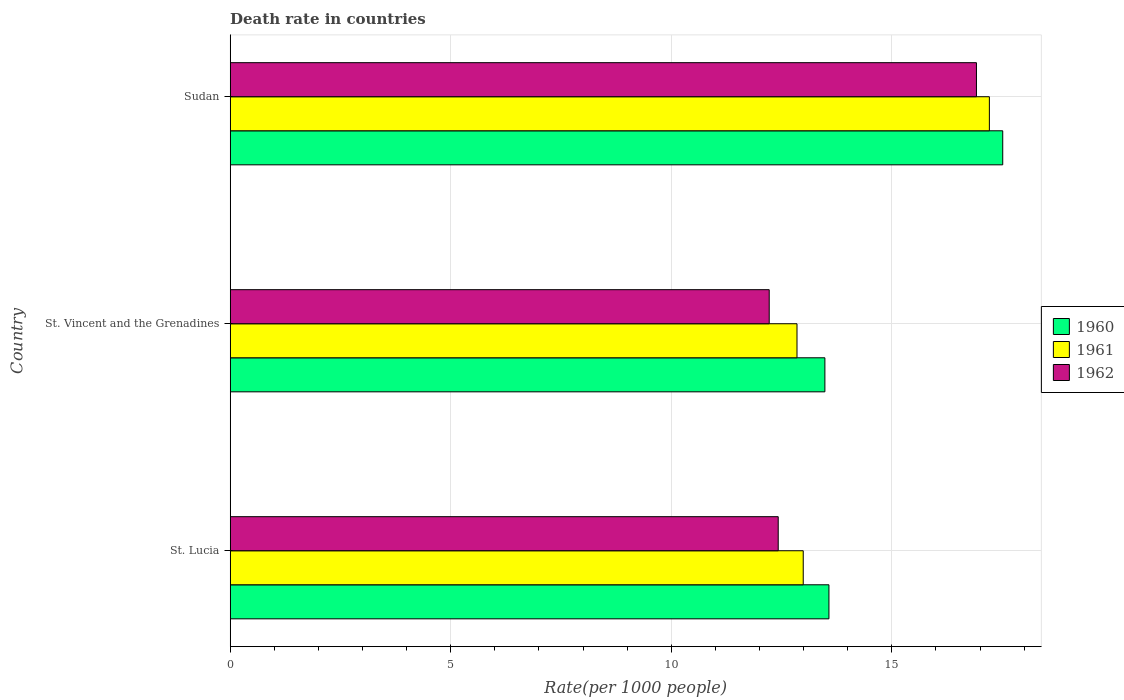How many bars are there on the 3rd tick from the top?
Provide a short and direct response. 3. What is the label of the 1st group of bars from the top?
Offer a terse response. Sudan. In how many cases, is the number of bars for a given country not equal to the number of legend labels?
Offer a very short reply. 0. What is the death rate in 1960 in St. Lucia?
Your answer should be very brief. 13.57. Across all countries, what is the maximum death rate in 1960?
Your answer should be compact. 17.51. Across all countries, what is the minimum death rate in 1961?
Ensure brevity in your answer.  12.85. In which country was the death rate in 1960 maximum?
Make the answer very short. Sudan. In which country was the death rate in 1960 minimum?
Provide a succinct answer. St. Vincent and the Grenadines. What is the total death rate in 1961 in the graph?
Offer a terse response. 43.05. What is the difference between the death rate in 1962 in St. Lucia and that in St. Vincent and the Grenadines?
Offer a terse response. 0.2. What is the difference between the death rate in 1960 in Sudan and the death rate in 1962 in St. Vincent and the Grenadines?
Ensure brevity in your answer.  5.29. What is the average death rate in 1962 per country?
Offer a terse response. 13.85. What is the difference between the death rate in 1961 and death rate in 1962 in St. Vincent and the Grenadines?
Your answer should be compact. 0.63. In how many countries, is the death rate in 1960 greater than 1 ?
Ensure brevity in your answer.  3. What is the ratio of the death rate in 1962 in St. Vincent and the Grenadines to that in Sudan?
Your response must be concise. 0.72. Is the difference between the death rate in 1961 in St. Lucia and Sudan greater than the difference between the death rate in 1962 in St. Lucia and Sudan?
Offer a very short reply. Yes. What is the difference between the highest and the second highest death rate in 1961?
Ensure brevity in your answer.  4.22. What is the difference between the highest and the lowest death rate in 1961?
Make the answer very short. 4.36. In how many countries, is the death rate in 1961 greater than the average death rate in 1961 taken over all countries?
Offer a terse response. 1. Is the sum of the death rate in 1962 in St. Lucia and Sudan greater than the maximum death rate in 1961 across all countries?
Offer a very short reply. Yes. Is it the case that in every country, the sum of the death rate in 1960 and death rate in 1961 is greater than the death rate in 1962?
Make the answer very short. Yes. Are all the bars in the graph horizontal?
Give a very brief answer. Yes. What is the difference between two consecutive major ticks on the X-axis?
Offer a very short reply. 5. Are the values on the major ticks of X-axis written in scientific E-notation?
Provide a short and direct response. No. Does the graph contain any zero values?
Ensure brevity in your answer.  No. Does the graph contain grids?
Your response must be concise. Yes. How many legend labels are there?
Provide a succinct answer. 3. What is the title of the graph?
Offer a terse response. Death rate in countries. Does "1979" appear as one of the legend labels in the graph?
Offer a terse response. No. What is the label or title of the X-axis?
Keep it short and to the point. Rate(per 1000 people). What is the Rate(per 1000 people) in 1960 in St. Lucia?
Offer a very short reply. 13.57. What is the Rate(per 1000 people) of 1961 in St. Lucia?
Provide a succinct answer. 12.99. What is the Rate(per 1000 people) in 1962 in St. Lucia?
Offer a very short reply. 12.42. What is the Rate(per 1000 people) of 1960 in St. Vincent and the Grenadines?
Provide a succinct answer. 13.48. What is the Rate(per 1000 people) of 1961 in St. Vincent and the Grenadines?
Your response must be concise. 12.85. What is the Rate(per 1000 people) of 1962 in St. Vincent and the Grenadines?
Ensure brevity in your answer.  12.22. What is the Rate(per 1000 people) of 1960 in Sudan?
Make the answer very short. 17.51. What is the Rate(per 1000 people) of 1961 in Sudan?
Give a very brief answer. 17.21. What is the Rate(per 1000 people) of 1962 in Sudan?
Provide a short and direct response. 16.92. Across all countries, what is the maximum Rate(per 1000 people) in 1960?
Offer a very short reply. 17.51. Across all countries, what is the maximum Rate(per 1000 people) in 1961?
Provide a succinct answer. 17.21. Across all countries, what is the maximum Rate(per 1000 people) of 1962?
Offer a terse response. 16.92. Across all countries, what is the minimum Rate(per 1000 people) of 1960?
Ensure brevity in your answer.  13.48. Across all countries, what is the minimum Rate(per 1000 people) of 1961?
Provide a succinct answer. 12.85. Across all countries, what is the minimum Rate(per 1000 people) of 1962?
Provide a short and direct response. 12.22. What is the total Rate(per 1000 people) of 1960 in the graph?
Your answer should be very brief. 44.57. What is the total Rate(per 1000 people) of 1961 in the graph?
Your response must be concise. 43.05. What is the total Rate(per 1000 people) of 1962 in the graph?
Your answer should be very brief. 41.56. What is the difference between the Rate(per 1000 people) of 1960 in St. Lucia and that in St. Vincent and the Grenadines?
Offer a very short reply. 0.09. What is the difference between the Rate(per 1000 people) in 1961 in St. Lucia and that in St. Vincent and the Grenadines?
Your answer should be compact. 0.14. What is the difference between the Rate(per 1000 people) of 1962 in St. Lucia and that in St. Vincent and the Grenadines?
Provide a succinct answer. 0.2. What is the difference between the Rate(per 1000 people) in 1960 in St. Lucia and that in Sudan?
Provide a short and direct response. -3.94. What is the difference between the Rate(per 1000 people) in 1961 in St. Lucia and that in Sudan?
Your answer should be very brief. -4.22. What is the difference between the Rate(per 1000 people) in 1962 in St. Lucia and that in Sudan?
Offer a terse response. -4.49. What is the difference between the Rate(per 1000 people) in 1960 in St. Vincent and the Grenadines and that in Sudan?
Give a very brief answer. -4.03. What is the difference between the Rate(per 1000 people) of 1961 in St. Vincent and the Grenadines and that in Sudan?
Make the answer very short. -4.36. What is the difference between the Rate(per 1000 people) of 1962 in St. Vincent and the Grenadines and that in Sudan?
Make the answer very short. -4.7. What is the difference between the Rate(per 1000 people) in 1960 in St. Lucia and the Rate(per 1000 people) in 1961 in St. Vincent and the Grenadines?
Offer a very short reply. 0.72. What is the difference between the Rate(per 1000 people) in 1960 in St. Lucia and the Rate(per 1000 people) in 1962 in St. Vincent and the Grenadines?
Your answer should be very brief. 1.35. What is the difference between the Rate(per 1000 people) of 1961 in St. Lucia and the Rate(per 1000 people) of 1962 in St. Vincent and the Grenadines?
Your response must be concise. 0.77. What is the difference between the Rate(per 1000 people) in 1960 in St. Lucia and the Rate(per 1000 people) in 1961 in Sudan?
Offer a terse response. -3.64. What is the difference between the Rate(per 1000 people) of 1960 in St. Lucia and the Rate(per 1000 people) of 1962 in Sudan?
Keep it short and to the point. -3.34. What is the difference between the Rate(per 1000 people) in 1961 in St. Lucia and the Rate(per 1000 people) in 1962 in Sudan?
Give a very brief answer. -3.93. What is the difference between the Rate(per 1000 people) in 1960 in St. Vincent and the Grenadines and the Rate(per 1000 people) in 1961 in Sudan?
Provide a succinct answer. -3.73. What is the difference between the Rate(per 1000 people) in 1960 in St. Vincent and the Grenadines and the Rate(per 1000 people) in 1962 in Sudan?
Give a very brief answer. -3.44. What is the difference between the Rate(per 1000 people) in 1961 in St. Vincent and the Grenadines and the Rate(per 1000 people) in 1962 in Sudan?
Make the answer very short. -4.07. What is the average Rate(per 1000 people) in 1960 per country?
Keep it short and to the point. 14.86. What is the average Rate(per 1000 people) in 1961 per country?
Your answer should be very brief. 14.35. What is the average Rate(per 1000 people) of 1962 per country?
Your response must be concise. 13.85. What is the difference between the Rate(per 1000 people) in 1960 and Rate(per 1000 people) in 1961 in St. Lucia?
Offer a very short reply. 0.58. What is the difference between the Rate(per 1000 people) of 1960 and Rate(per 1000 people) of 1962 in St. Lucia?
Give a very brief answer. 1.15. What is the difference between the Rate(per 1000 people) in 1961 and Rate(per 1000 people) in 1962 in St. Lucia?
Your response must be concise. 0.57. What is the difference between the Rate(per 1000 people) of 1960 and Rate(per 1000 people) of 1961 in St. Vincent and the Grenadines?
Provide a succinct answer. 0.63. What is the difference between the Rate(per 1000 people) of 1960 and Rate(per 1000 people) of 1962 in St. Vincent and the Grenadines?
Give a very brief answer. 1.26. What is the difference between the Rate(per 1000 people) in 1961 and Rate(per 1000 people) in 1962 in St. Vincent and the Grenadines?
Make the answer very short. 0.63. What is the difference between the Rate(per 1000 people) in 1960 and Rate(per 1000 people) in 1961 in Sudan?
Your response must be concise. 0.3. What is the difference between the Rate(per 1000 people) in 1960 and Rate(per 1000 people) in 1962 in Sudan?
Keep it short and to the point. 0.6. What is the difference between the Rate(per 1000 people) in 1961 and Rate(per 1000 people) in 1962 in Sudan?
Provide a short and direct response. 0.29. What is the ratio of the Rate(per 1000 people) in 1960 in St. Lucia to that in St. Vincent and the Grenadines?
Provide a short and direct response. 1.01. What is the ratio of the Rate(per 1000 people) in 1961 in St. Lucia to that in St. Vincent and the Grenadines?
Your response must be concise. 1.01. What is the ratio of the Rate(per 1000 people) of 1962 in St. Lucia to that in St. Vincent and the Grenadines?
Ensure brevity in your answer.  1.02. What is the ratio of the Rate(per 1000 people) in 1960 in St. Lucia to that in Sudan?
Keep it short and to the point. 0.78. What is the ratio of the Rate(per 1000 people) in 1961 in St. Lucia to that in Sudan?
Keep it short and to the point. 0.75. What is the ratio of the Rate(per 1000 people) of 1962 in St. Lucia to that in Sudan?
Your response must be concise. 0.73. What is the ratio of the Rate(per 1000 people) in 1960 in St. Vincent and the Grenadines to that in Sudan?
Make the answer very short. 0.77. What is the ratio of the Rate(per 1000 people) of 1961 in St. Vincent and the Grenadines to that in Sudan?
Provide a succinct answer. 0.75. What is the ratio of the Rate(per 1000 people) in 1962 in St. Vincent and the Grenadines to that in Sudan?
Offer a very short reply. 0.72. What is the difference between the highest and the second highest Rate(per 1000 people) of 1960?
Give a very brief answer. 3.94. What is the difference between the highest and the second highest Rate(per 1000 people) of 1961?
Provide a short and direct response. 4.22. What is the difference between the highest and the second highest Rate(per 1000 people) in 1962?
Offer a terse response. 4.49. What is the difference between the highest and the lowest Rate(per 1000 people) in 1960?
Offer a very short reply. 4.03. What is the difference between the highest and the lowest Rate(per 1000 people) in 1961?
Make the answer very short. 4.36. What is the difference between the highest and the lowest Rate(per 1000 people) in 1962?
Offer a terse response. 4.7. 